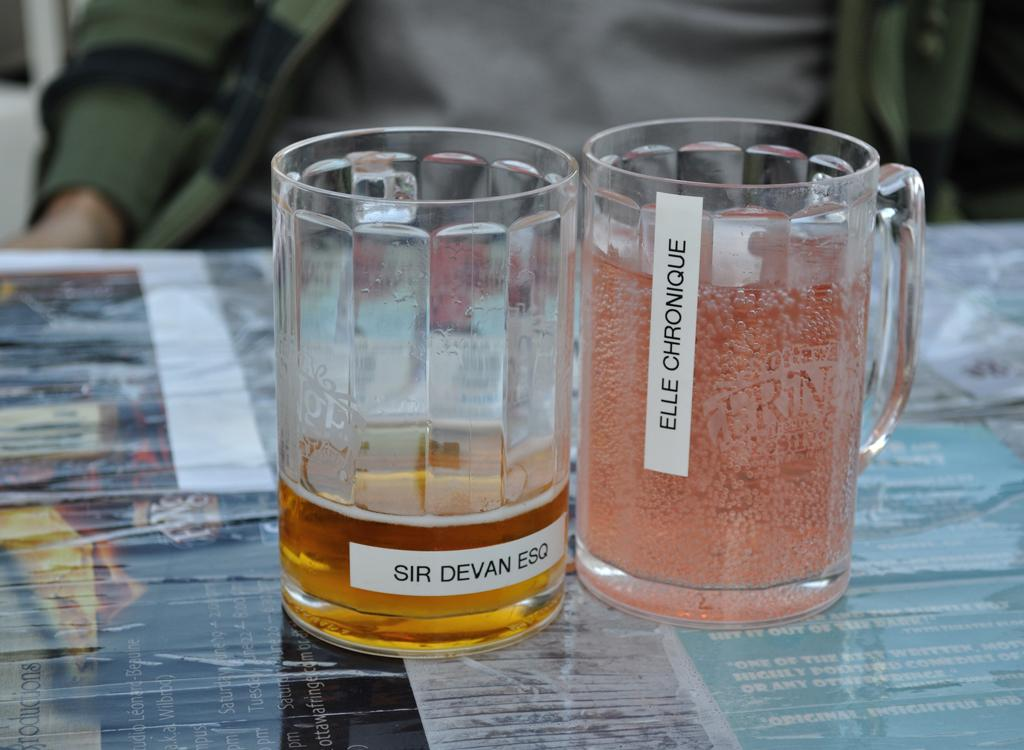<image>
Render a clear and concise summary of the photo. the word Devan is on the beer mug 